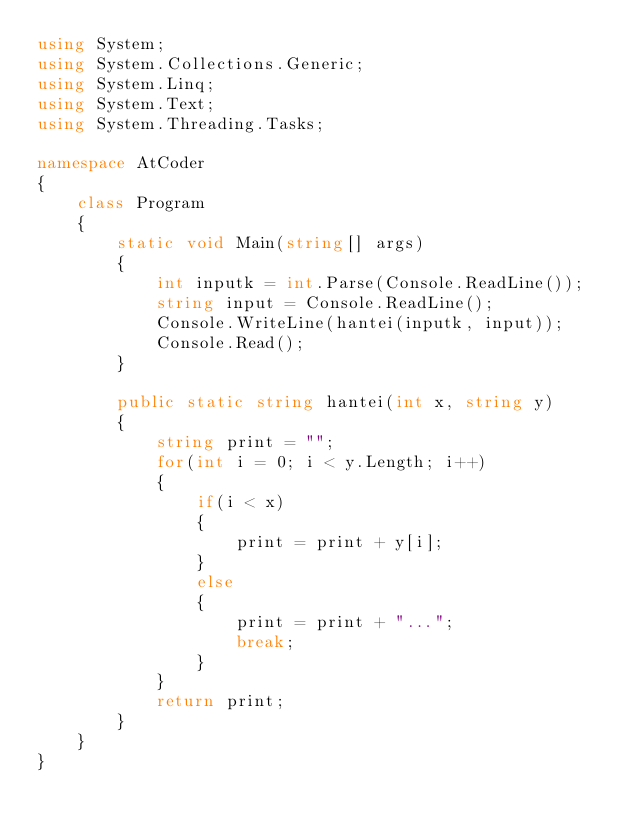<code> <loc_0><loc_0><loc_500><loc_500><_C#_>using System;
using System.Collections.Generic;
using System.Linq;
using System.Text;
using System.Threading.Tasks;

namespace AtCoder
{
    class Program
    {
        static void Main(string[] args)
        {
            int inputk = int.Parse(Console.ReadLine());
            string input = Console.ReadLine();
            Console.WriteLine(hantei(inputk, input));
            Console.Read();
        }

        public static string hantei(int x, string y)
        {
            string print = "";
            for(int i = 0; i < y.Length; i++)
            {
                if(i < x)
                {
                    print = print + y[i];
                }
                else
                {
                    print = print + "...";
                    break;
                }
            }
            return print;
        }
    }
}
</code> 